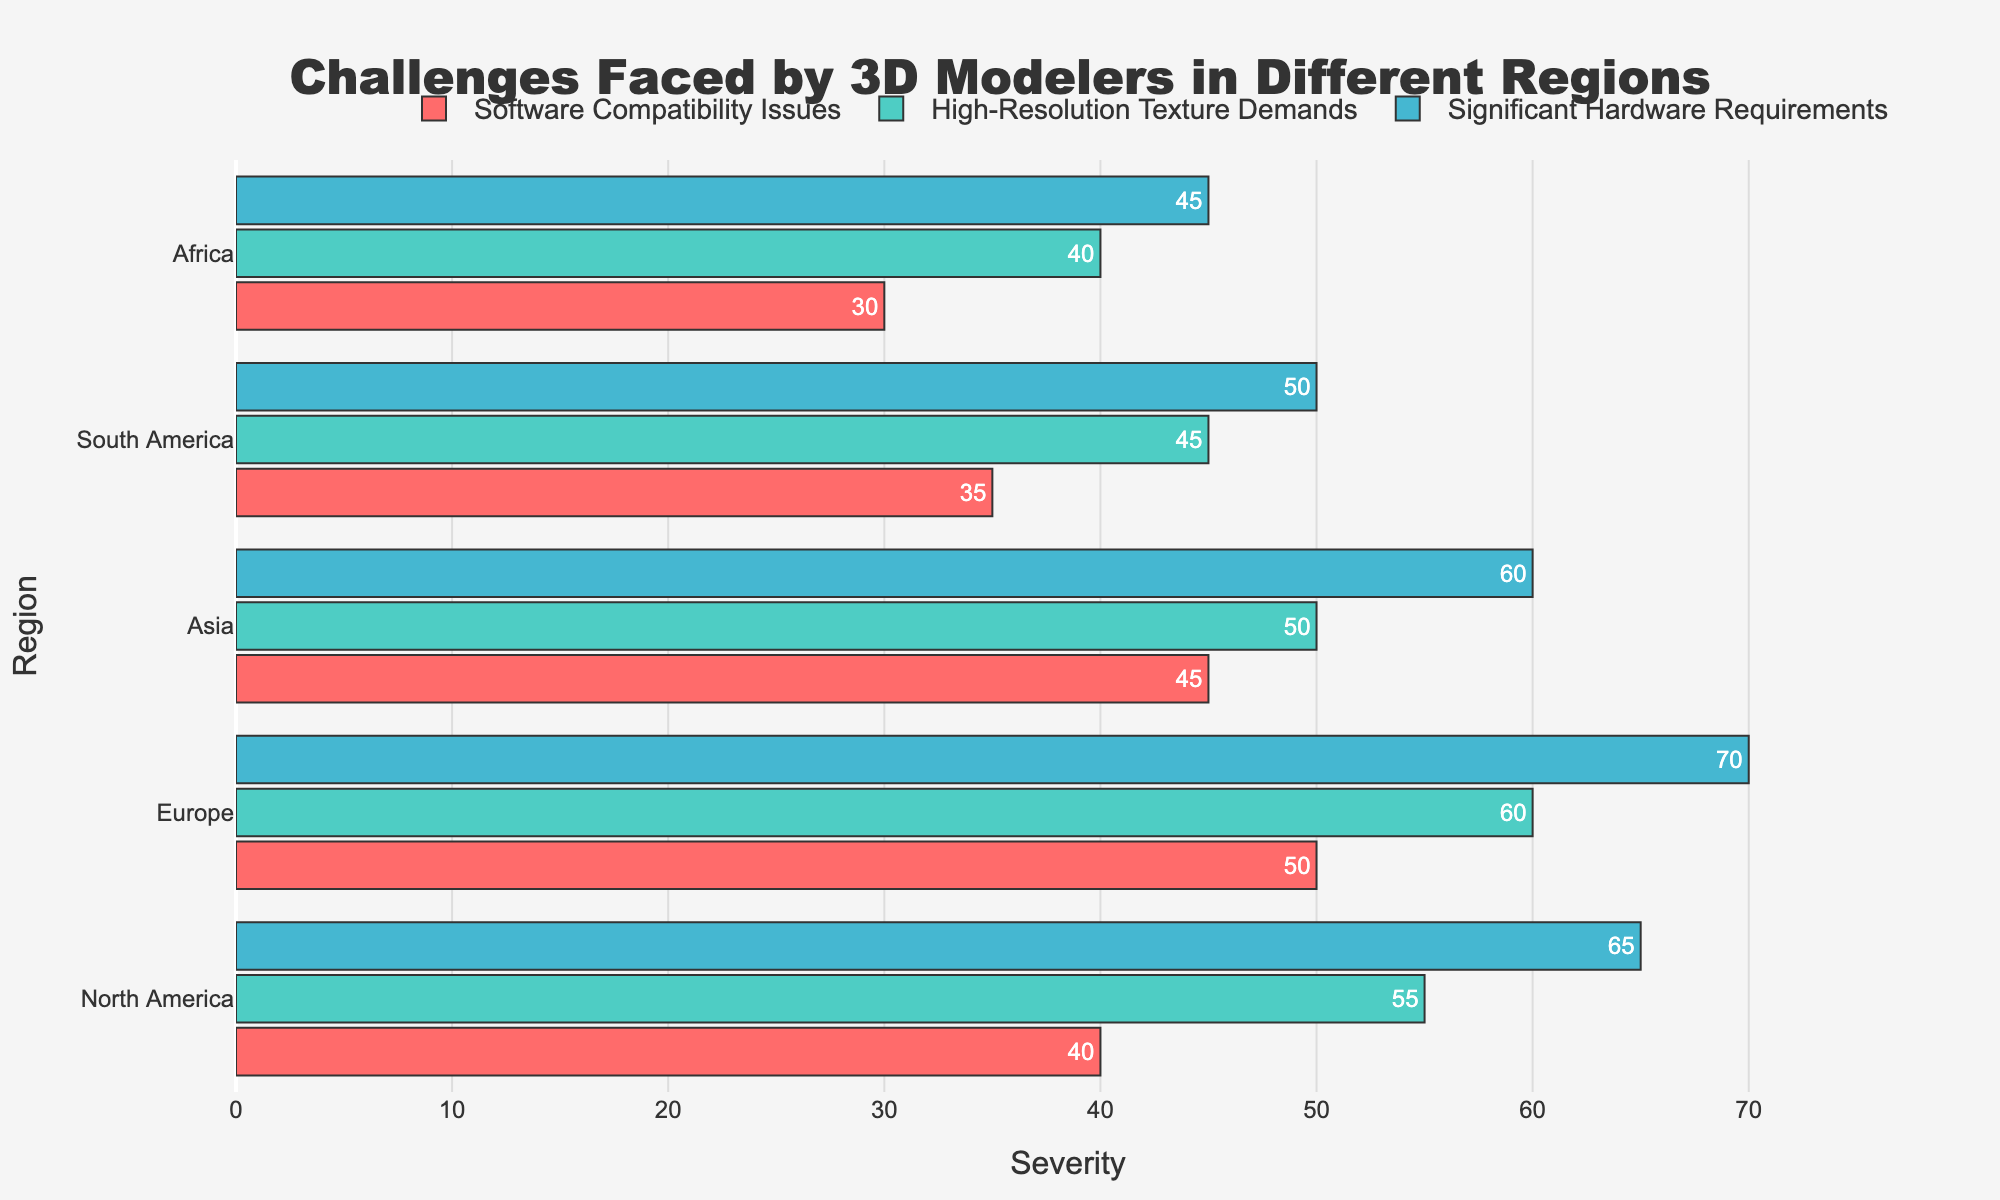Which region faces the highest severity for significant hardware requirements? By observing the lengths of the bars representing "Significant Hardware Requirements", Europe has the longest bar, indicating the highest severity.
Answer: Europe Among the regions, which one has the least severity for software compatibility issues? By looking at the lengths of the bars representing "Software Compatibility Issues", Africa has the shortest bar, indicating the least severity.
Answer: Africa What is the difference in severity for high-resolution texture demands between North America and South America? The bar lengths for "High-Resolution Texture Demands" are 55 for North America and 45 for South America. The difference is 55 - 45 = 10.
Answer: 10 Compare the severity of software compatibility issues in North America to Asia. Which region has a higher severity? North America's bar for "Software Compatibility Issues" is at 40, whereas Asia's bar is at 45. Thus, Asia has a higher severity.
Answer: Asia What's the average severity of high-resolution texture demands for all regions? Sum the severities for "High-Resolution Texture Demands" across all regions: 55 (North America) + 60 (Europe) + 50 (Asia) + 45 (South America) + 40 (Africa) = 250. There are 5 regions, so the average is 250 / 5 = 50.
Answer: 50 Is the severity of significant hardware requirements in Europe greater than the combined severities of software compatibility issues and high-resolution texture demands in Africa? The severity for "Significant Hardware Requirements" in Europe is 70. For Africa, the sum of "Software Compatibility Issues" (30) and "High-Resolution Texture Demands" (40) is 30 + 40 = 70. Thus, the severity in Europe is equal to the combined severities in Africa.
Answer: Equal Which challenge has the highest severity in South America? Comparing the bars for South America, "Significant Hardware Requirements" has the longest bar at 50.
Answer: Significant Hardware Requirements If we combine the severity of significant hardware requirements across all regions, what is the total? Sum the severities for "Significant Hardware Requirements" across all regions: 65 (North America) + 70 (Europe) + 60 (Asia) + 50 (South America) + 45 (Africa) = 290.
Answer: 290 Compare the severity of high-resolution texture demands across all regions. Which region shows the lowest value? The bar lengths for "High-Resolution Texture Demands" are 55 (North America), 60 (Europe), 50 (Asia), 45 (South America), and 40 (Africa). Africa has the lowest bar at 40.
Answer: Africa 